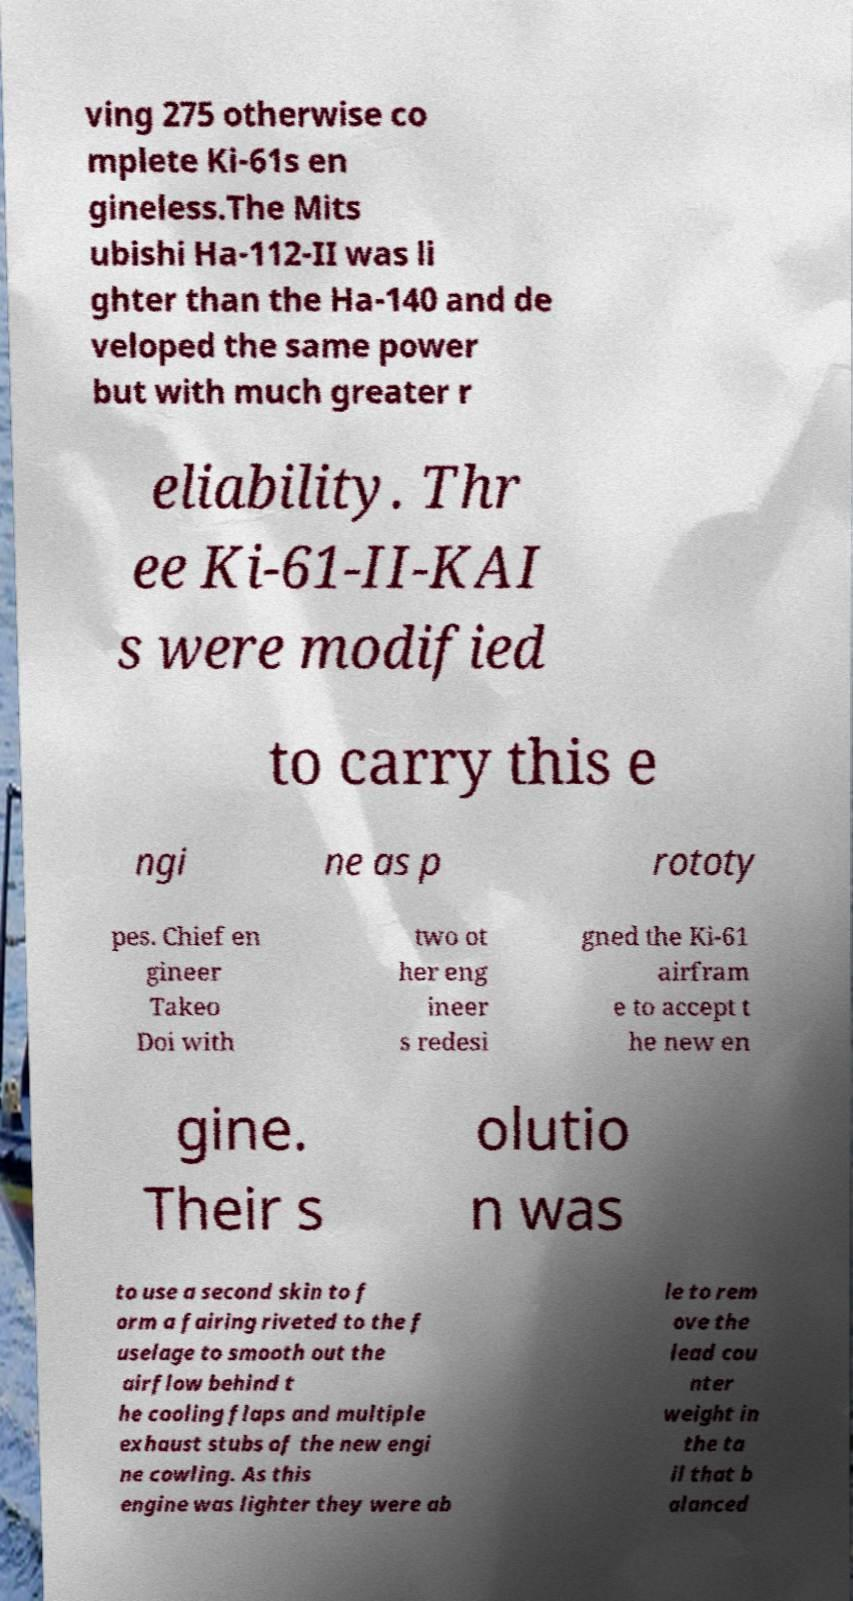Please identify and transcribe the text found in this image. ving 275 otherwise co mplete Ki-61s en gineless.The Mits ubishi Ha-112-II was li ghter than the Ha-140 and de veloped the same power but with much greater r eliability. Thr ee Ki-61-II-KAI s were modified to carry this e ngi ne as p rototy pes. Chief en gineer Takeo Doi with two ot her eng ineer s redesi gned the Ki-61 airfram e to accept t he new en gine. Their s olutio n was to use a second skin to f orm a fairing riveted to the f uselage to smooth out the airflow behind t he cooling flaps and multiple exhaust stubs of the new engi ne cowling. As this engine was lighter they were ab le to rem ove the lead cou nter weight in the ta il that b alanced 